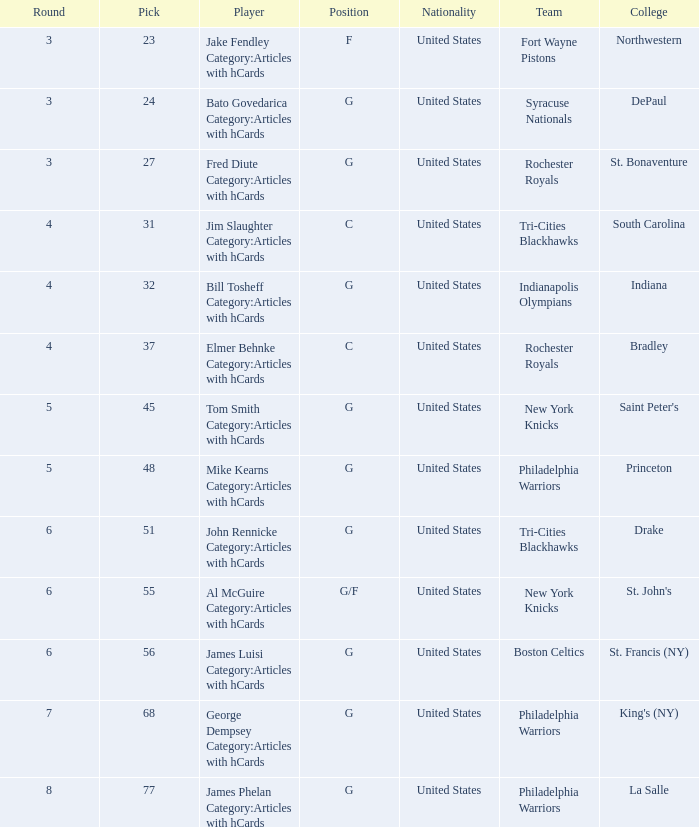Can you give me this table as a dict? {'header': ['Round', 'Pick', 'Player', 'Position', 'Nationality', 'Team', 'College'], 'rows': [['3', '23', 'Jake Fendley Category:Articles with hCards', 'F', 'United States', 'Fort Wayne Pistons', 'Northwestern'], ['3', '24', 'Bato Govedarica Category:Articles with hCards', 'G', 'United States', 'Syracuse Nationals', 'DePaul'], ['3', '27', 'Fred Diute Category:Articles with hCards', 'G', 'United States', 'Rochester Royals', 'St. Bonaventure'], ['4', '31', 'Jim Slaughter Category:Articles with hCards', 'C', 'United States', 'Tri-Cities Blackhawks', 'South Carolina'], ['4', '32', 'Bill Tosheff Category:Articles with hCards', 'G', 'United States', 'Indianapolis Olympians', 'Indiana'], ['4', '37', 'Elmer Behnke Category:Articles with hCards', 'C', 'United States', 'Rochester Royals', 'Bradley'], ['5', '45', 'Tom Smith Category:Articles with hCards', 'G', 'United States', 'New York Knicks', "Saint Peter's"], ['5', '48', 'Mike Kearns Category:Articles with hCards', 'G', 'United States', 'Philadelphia Warriors', 'Princeton'], ['6', '51', 'John Rennicke Category:Articles with hCards', 'G', 'United States', 'Tri-Cities Blackhawks', 'Drake'], ['6', '55', 'Al McGuire Category:Articles with hCards', 'G/F', 'United States', 'New York Knicks', "St. John's"], ['6', '56', 'James Luisi Category:Articles with hCards', 'G', 'United States', 'Boston Celtics', 'St. Francis (NY)'], ['7', '68', 'George Dempsey Category:Articles with hCards', 'G', 'United States', 'Philadelphia Warriors', "King's (NY)"], ['8', '77', 'James Phelan Category:Articles with hCards', 'G', 'United States', 'Philadelphia Warriors', 'La Salle']]} What is the cumulative number of selections for drake players from the tri-cities blackhawks? 51.0. 